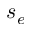Convert formula to latex. <formula><loc_0><loc_0><loc_500><loc_500>s _ { e }</formula> 